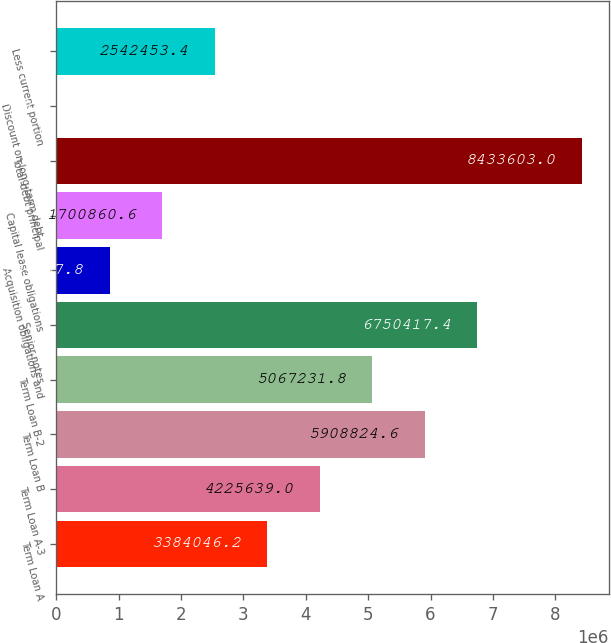Convert chart. <chart><loc_0><loc_0><loc_500><loc_500><bar_chart><fcel>Term Loan A<fcel>Term Loan A-3<fcel>Term Loan B<fcel>Term Loan B-2<fcel>Senior notes<fcel>Acquisition obligations and<fcel>Capital lease obligations<fcel>Total debt principal<fcel>Discount on long-term debt<fcel>Less current portion<nl><fcel>3.38405e+06<fcel>4.22564e+06<fcel>5.90882e+06<fcel>5.06723e+06<fcel>6.75042e+06<fcel>859268<fcel>1.70086e+06<fcel>8.4336e+06<fcel>17675<fcel>2.54245e+06<nl></chart> 